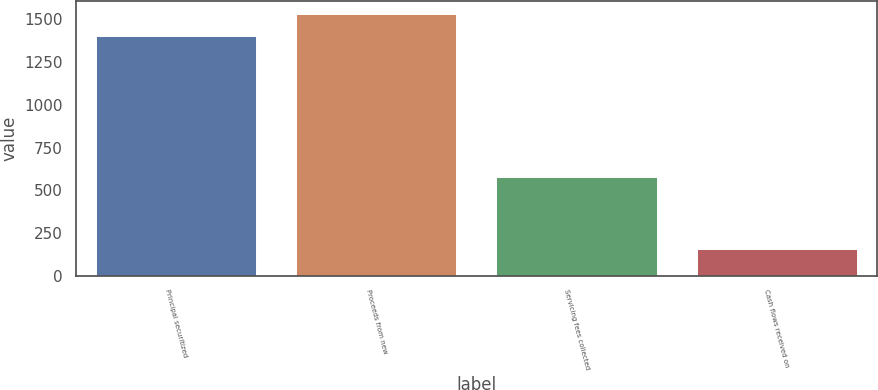Convert chart to OTSL. <chart><loc_0><loc_0><loc_500><loc_500><bar_chart><fcel>Principal securitized<fcel>Proceeds from new<fcel>Servicing fees collected<fcel>Cash flows received on<nl><fcel>1404<fcel>1529.4<fcel>576<fcel>156<nl></chart> 